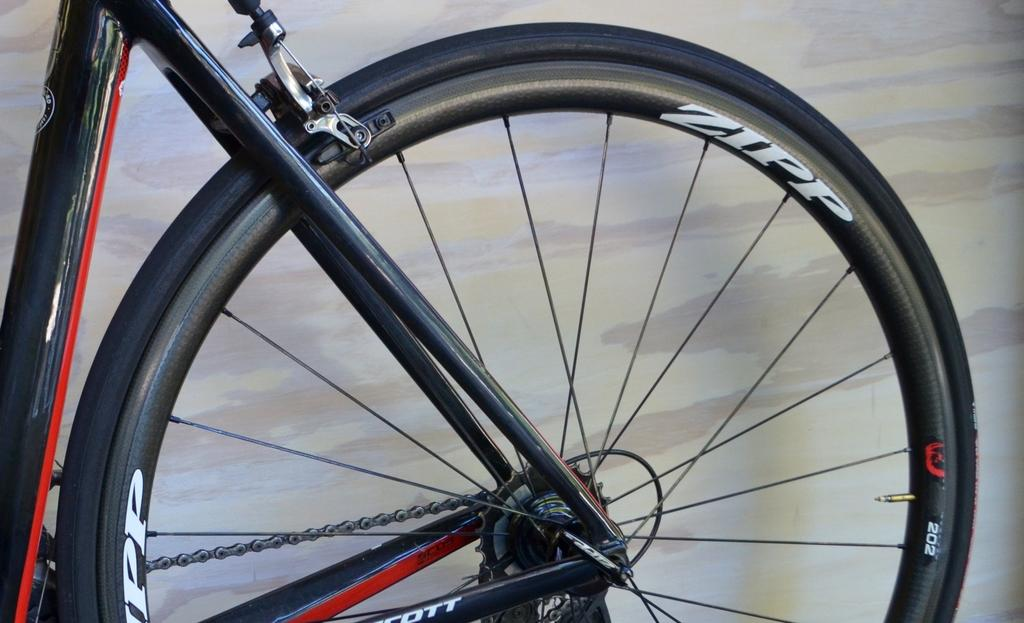What is the main object in the image? There is a bicycle wheel in the image. Can you describe the background of the image? There is a wall visible behind the bicycle wheel. What letter is written on the wall behind the bicycle wheel? There is no letter written on the wall behind the bicycle wheel in the image. 